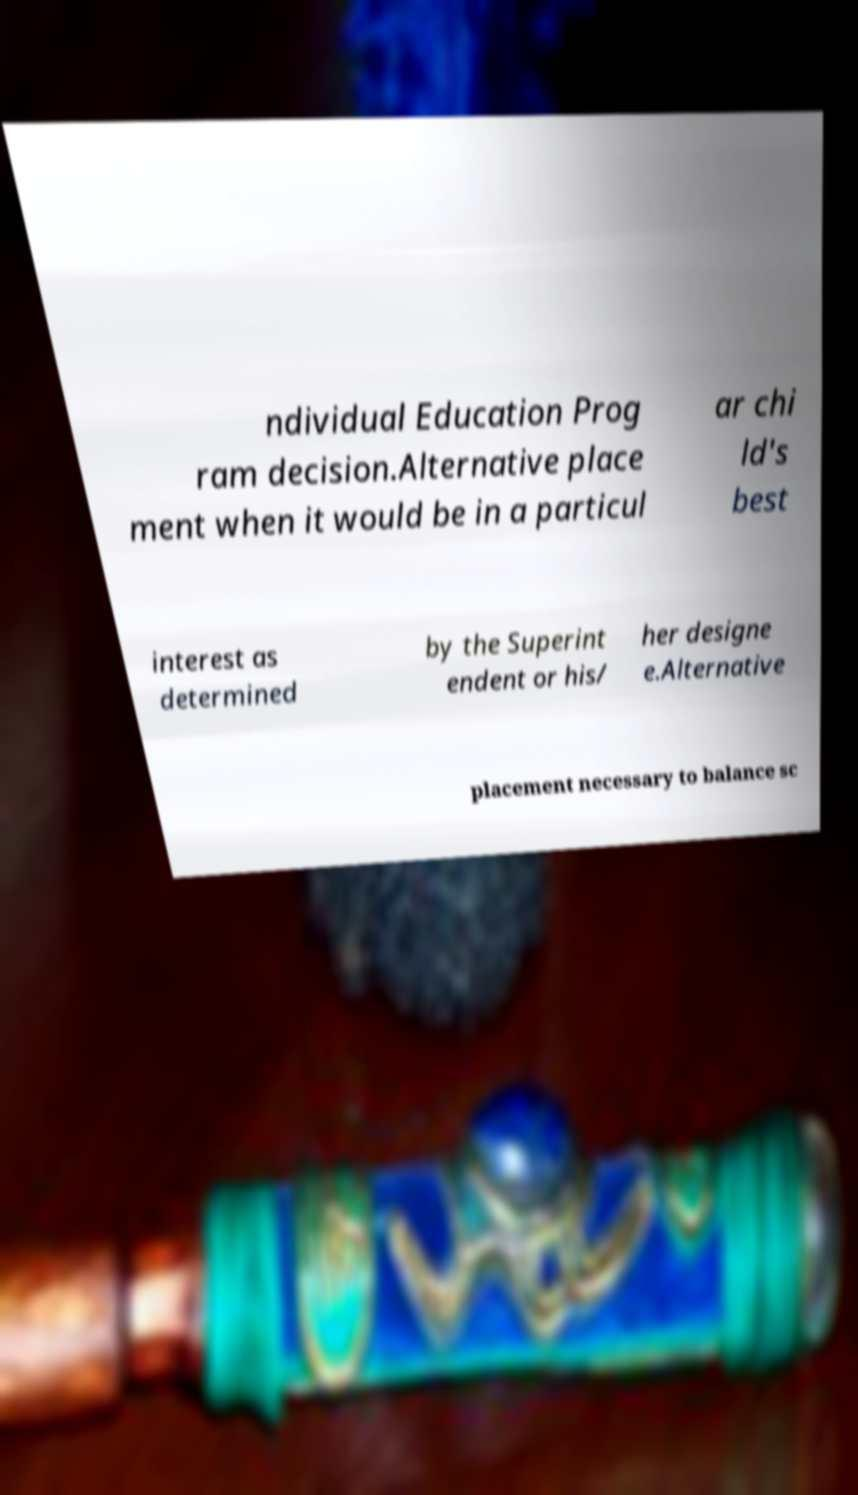I need the written content from this picture converted into text. Can you do that? ndividual Education Prog ram decision.Alternative place ment when it would be in a particul ar chi ld's best interest as determined by the Superint endent or his/ her designe e.Alternative placement necessary to balance sc 